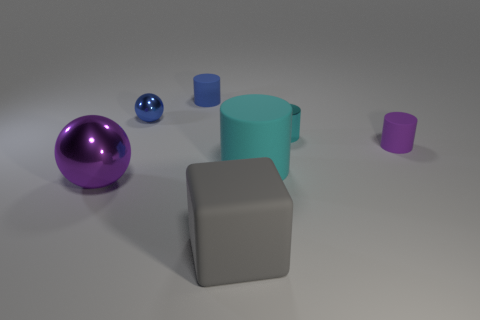Subtract all tiny cyan cylinders. How many cylinders are left? 3 Add 2 cubes. How many objects exist? 9 Subtract all purple spheres. How many spheres are left? 1 Subtract all balls. How many objects are left? 5 Subtract all green cubes. How many cyan cylinders are left? 2 Add 6 blue matte cylinders. How many blue matte cylinders are left? 7 Add 6 purple blocks. How many purple blocks exist? 6 Subtract 0 brown blocks. How many objects are left? 7 Subtract 3 cylinders. How many cylinders are left? 1 Subtract all brown cylinders. Subtract all blue spheres. How many cylinders are left? 4 